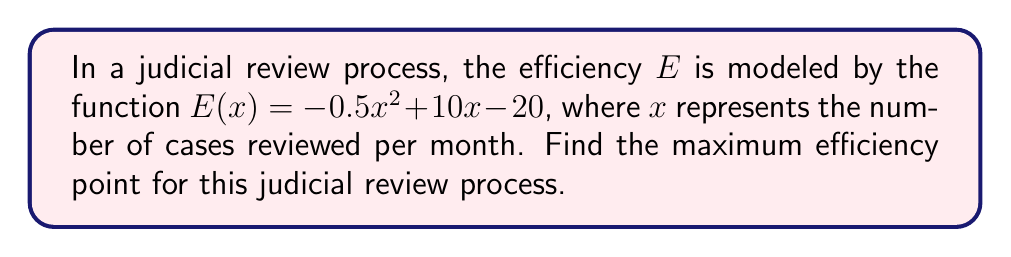Could you help me with this problem? To find the maximum efficiency point, we need to follow these steps:

1. The efficiency function $E(x)$ is a quadratic function. The maximum point of a quadratic function occurs at the vertex of the parabola.

2. For a quadratic function in the form $f(x) = ax^2 + bx + c$, the x-coordinate of the vertex is given by $x = -\frac{b}{2a}$.

3. In our case, $a = -0.5$, $b = 10$, and $c = -20$.

4. Substituting these values into the vertex formula:

   $x = -\frac{10}{2(-0.5)} = -\frac{10}{-1} = 10$

5. To find the maximum efficiency, we substitute $x = 10$ into the original function:

   $E(10) = -0.5(10)^2 + 10(10) - 20$
   $= -0.5(100) + 100 - 20$
   $= -50 + 100 - 20$
   $= 30$

6. Therefore, the maximum efficiency point occurs at $(10, 30)$.
Answer: $(10, 30)$ 